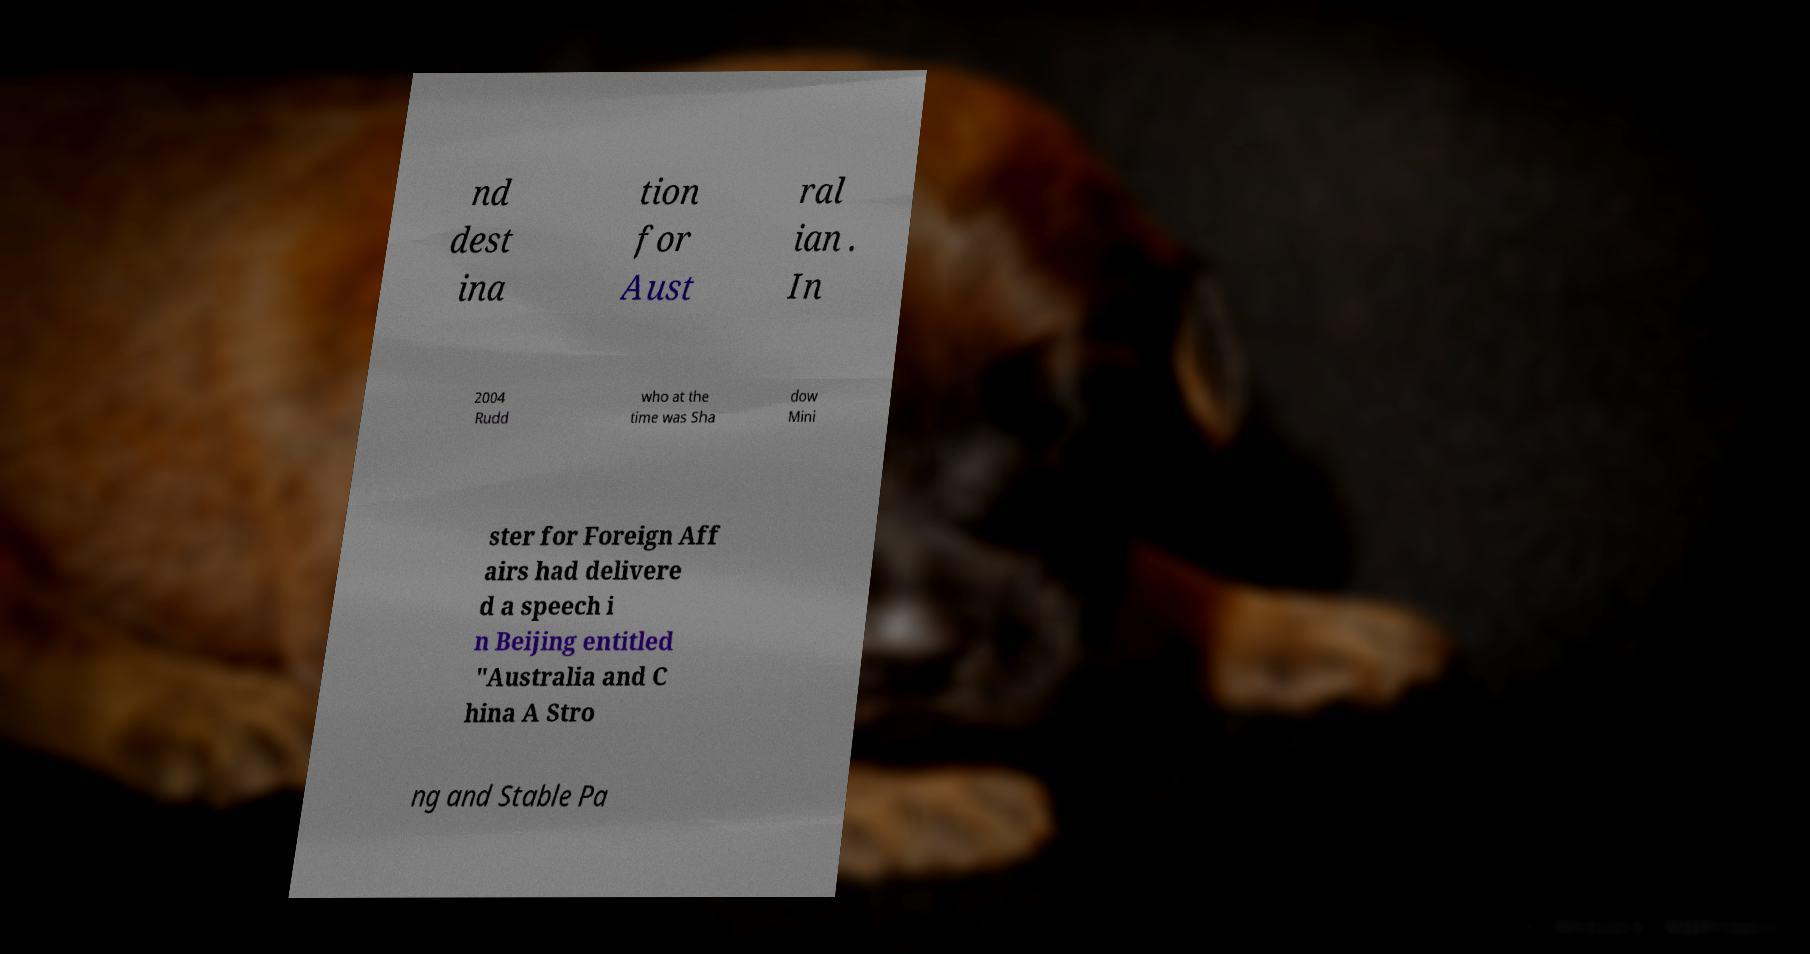Can you read and provide the text displayed in the image?This photo seems to have some interesting text. Can you extract and type it out for me? nd dest ina tion for Aust ral ian . In 2004 Rudd who at the time was Sha dow Mini ster for Foreign Aff airs had delivere d a speech i n Beijing entitled "Australia and C hina A Stro ng and Stable Pa 